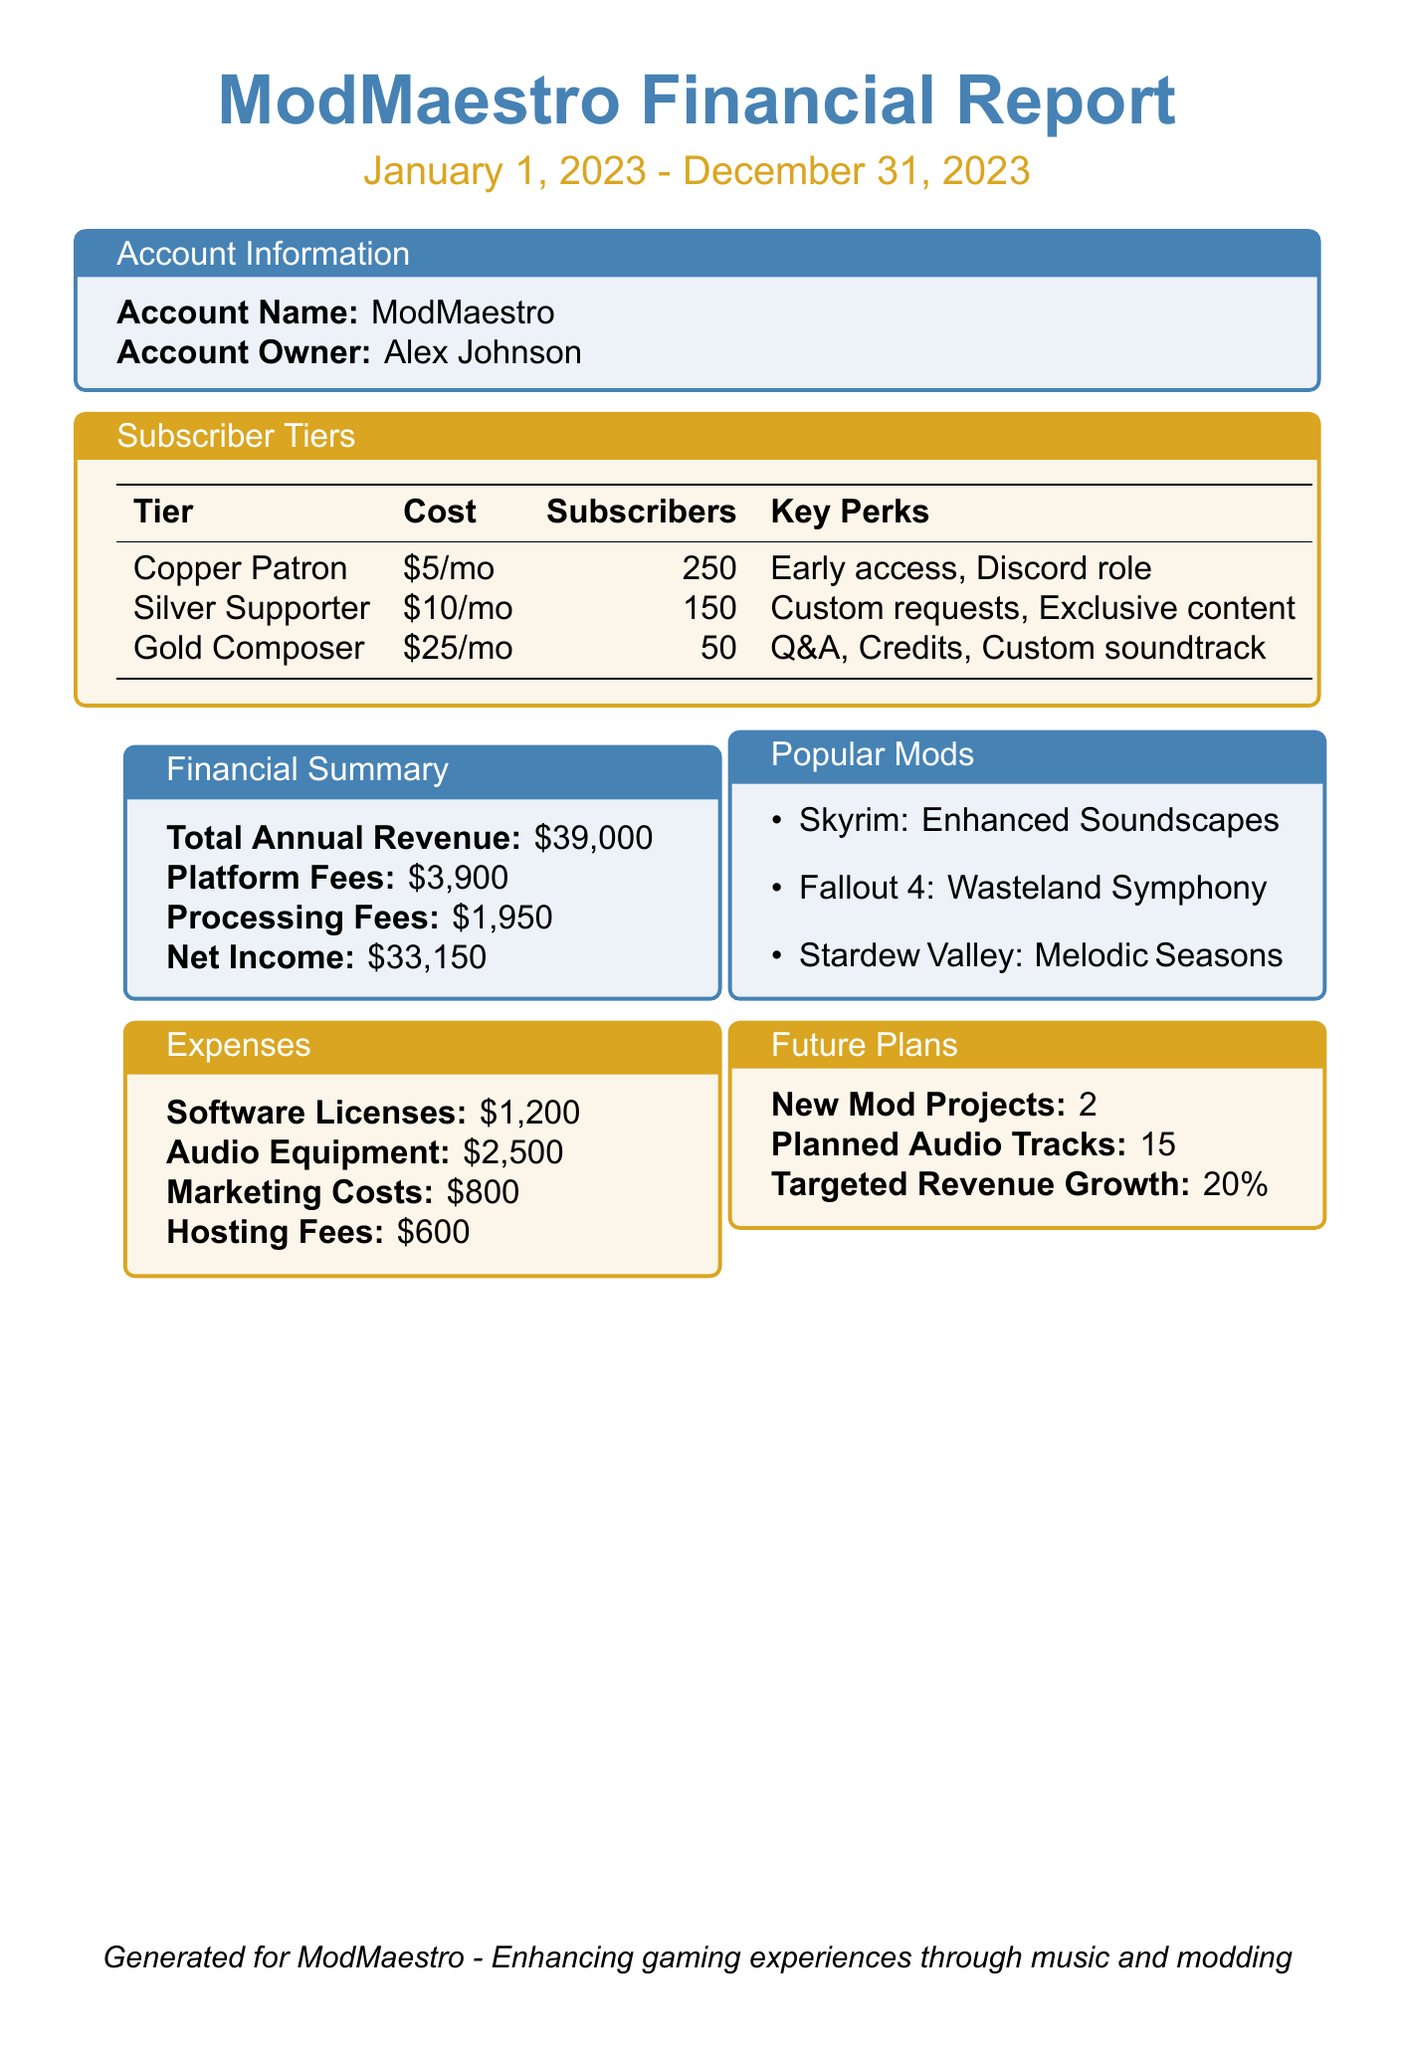What is the account owner's name? The account owner's name is explicitly stated in the account information section of the document.
Answer: Alex Johnson How much does the Gold Composer tier cost per month? This information is found in the subscriber tiers section, which lists the monthly costs for each tier.
Answer: $25 What is the total annual revenue? The total annual revenue is provided in the financial summary section of the report.
Answer: $39,000 How many subscribers are in the Silver Supporter tier? The number of subscribers for the Silver Supporter tier is indicated in the subscriber tiers section.
Answer: 150 What are the marketing costs for the year? Marketing costs are detailed under the expenses section, indicating how much was spent in this area.
Answer: $800 What is the targeted revenue growth percentage? The target for revenue growth is specified in the future plans section of the report.
Answer: 20% How many popular mods are referenced? The number of mods listed as popular in the document is clearly outlined in the popular mods section.
Answer: 3 What perks are included in the Copper Patron tier? This question pertains to the specific features provided within the Copper Patron tier found in the subscriber tiers section.
Answer: Early access to mod updates, Discord role How many planned audio tracks are there? The planned number of audio tracks is stated in the future plans section, showing intentions for future work.
Answer: 15 